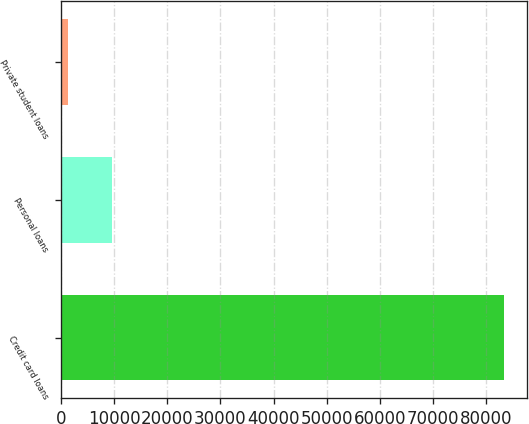<chart> <loc_0><loc_0><loc_500><loc_500><bar_chart><fcel>Credit card loans<fcel>Personal loans<fcel>Private student loans<nl><fcel>83479<fcel>9573.7<fcel>1362<nl></chart> 